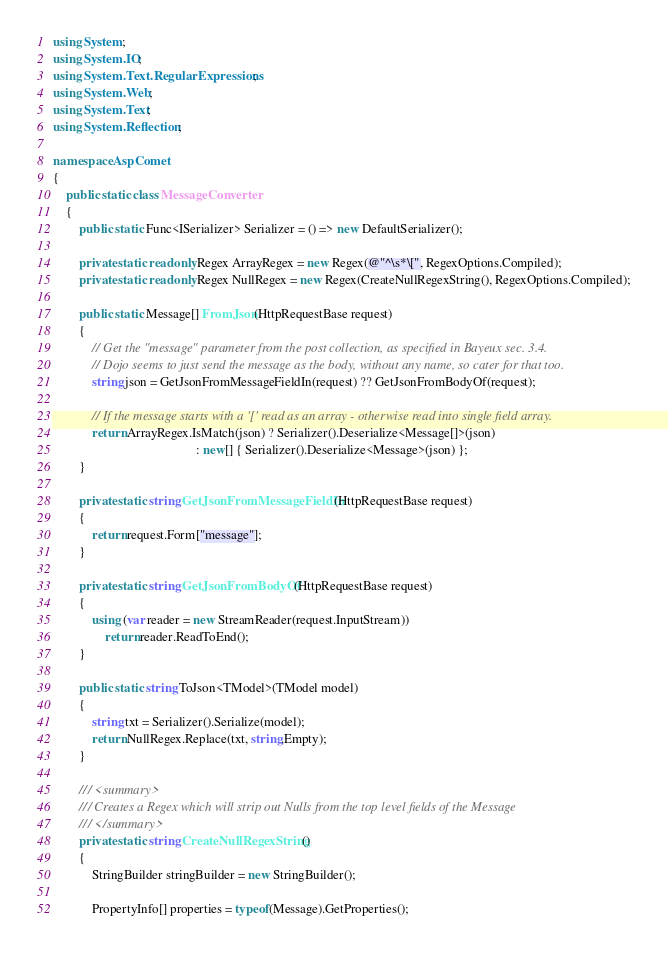Convert code to text. <code><loc_0><loc_0><loc_500><loc_500><_C#_>using System;
using System.IO;
using System.Text.RegularExpressions;
using System.Web;
using System.Text;
using System.Reflection;

namespace AspComet
{
    public static class MessageConverter 
    {
        public static Func<ISerializer> Serializer = () => new DefaultSerializer();

        private static readonly Regex ArrayRegex = new Regex(@"^\s*\[", RegexOptions.Compiled);
        private static readonly Regex NullRegex = new Regex(CreateNullRegexString(), RegexOptions.Compiled);

        public static Message[] FromJson(HttpRequestBase request)
        {
            // Get the "message" parameter from the post collection, as specified in Bayeux sec. 3.4.
            // Dojo seems to just send the message as the body, without any name, so cater for that too.
            string json = GetJsonFromMessageFieldIn(request) ?? GetJsonFromBodyOf(request);

            // If the message starts with a '[' read as an array - otherwise read into single field array.
            return ArrayRegex.IsMatch(json) ? Serializer().Deserialize<Message[]>(json)
                                            : new[] { Serializer().Deserialize<Message>(json) };
        }

        private static string GetJsonFromMessageFieldIn(HttpRequestBase request)
        {
            return request.Form["message"];
        }

        private static string GetJsonFromBodyOf(HttpRequestBase request)
        {
            using (var reader = new StreamReader(request.InputStream))
                return reader.ReadToEnd();
        }

        public static string ToJson<TModel>(TModel model)
        {
            string txt = Serializer().Serialize(model);
            return NullRegex.Replace(txt, string.Empty);
        }

        /// <summary>
        /// Creates a Regex which will strip out Nulls from the top level fields of the Message
        /// </summary>
        private static string CreateNullRegexString()
        {
            StringBuilder stringBuilder = new StringBuilder();

            PropertyInfo[] properties = typeof(Message).GetProperties();</code> 